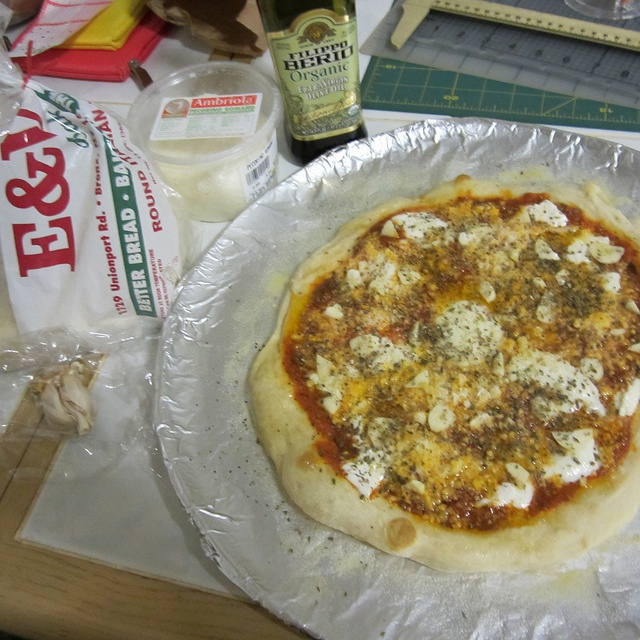Describe the objects in this image and their specific colors. I can see dining table in darkgray, tan, gray, and olive tones, pizza in gray, tan, and olive tones, bowl in gray, darkgray, and lightgray tones, and bottle in gray, olive, black, and darkgray tones in this image. 